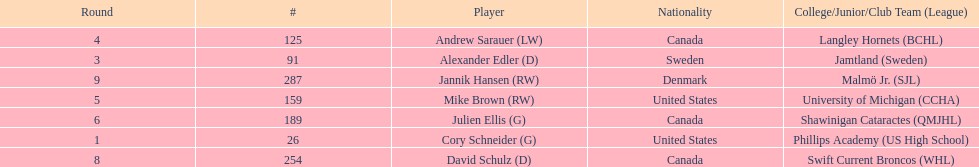How many goalies drafted? 2. 